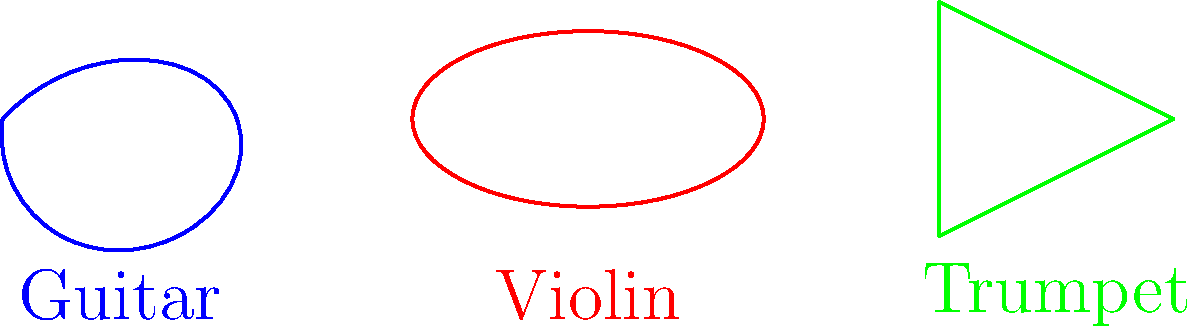As a vocal coach working with young singers, you often discuss the shapes of various musical instruments to help them understand resonance and sound production. Consider the symmetry groups of the three instrument shapes shown above: a guitar, a violin, and a trumpet. Which of these instruments has the highest order of rotational symmetry, and what is that order? Let's analyze the symmetry of each instrument shape:

1. Guitar:
   - The guitar shape has reflection symmetry across its vertical axis.
   - It has no rotational symmetry other than the trivial 360° rotation.
   - Order of rotational symmetry: 1

2. Violin:
   - The violin shape (simplified as an ellipse) has two lines of reflection symmetry: vertical and horizontal.
   - It has 180° rotational symmetry (2-fold rotation).
   - Order of rotational symmetry: 2

3. Trumpet:
   - The simplified trumpet shape (represented as an isosceles triangle) has one line of reflection symmetry.
   - It has 360°, 120°, and 240° rotational symmetry (3-fold rotation).
   - Order of rotational symmetry: 3

Comparing the orders of rotational symmetry:
Guitar: 1
Violin: 2
Trumpet: 3

The trumpet has the highest order of rotational symmetry among the three instruments.
Answer: Trumpet, order 3 